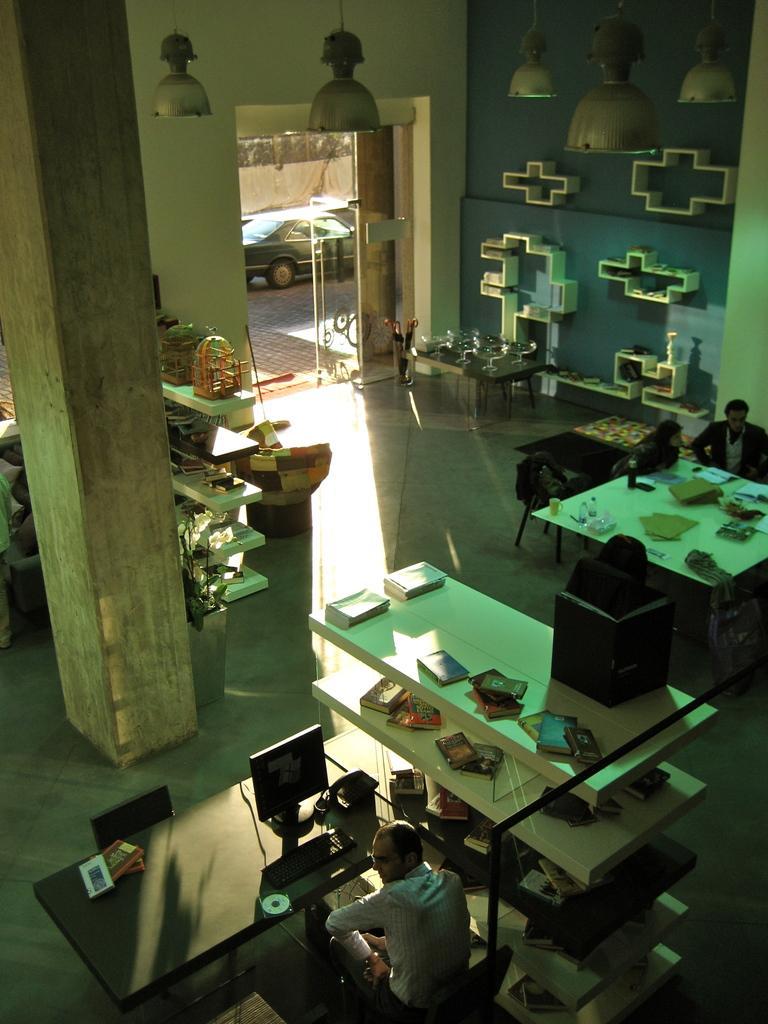In one or two sentences, can you explain what this image depicts? There is a room here and we can see a pillar. In front of the pillar there is a table on which a computer is placed. A man is sitting in front of a computer. Beside him there are some cupboards. In the background we can observe some cars here. 